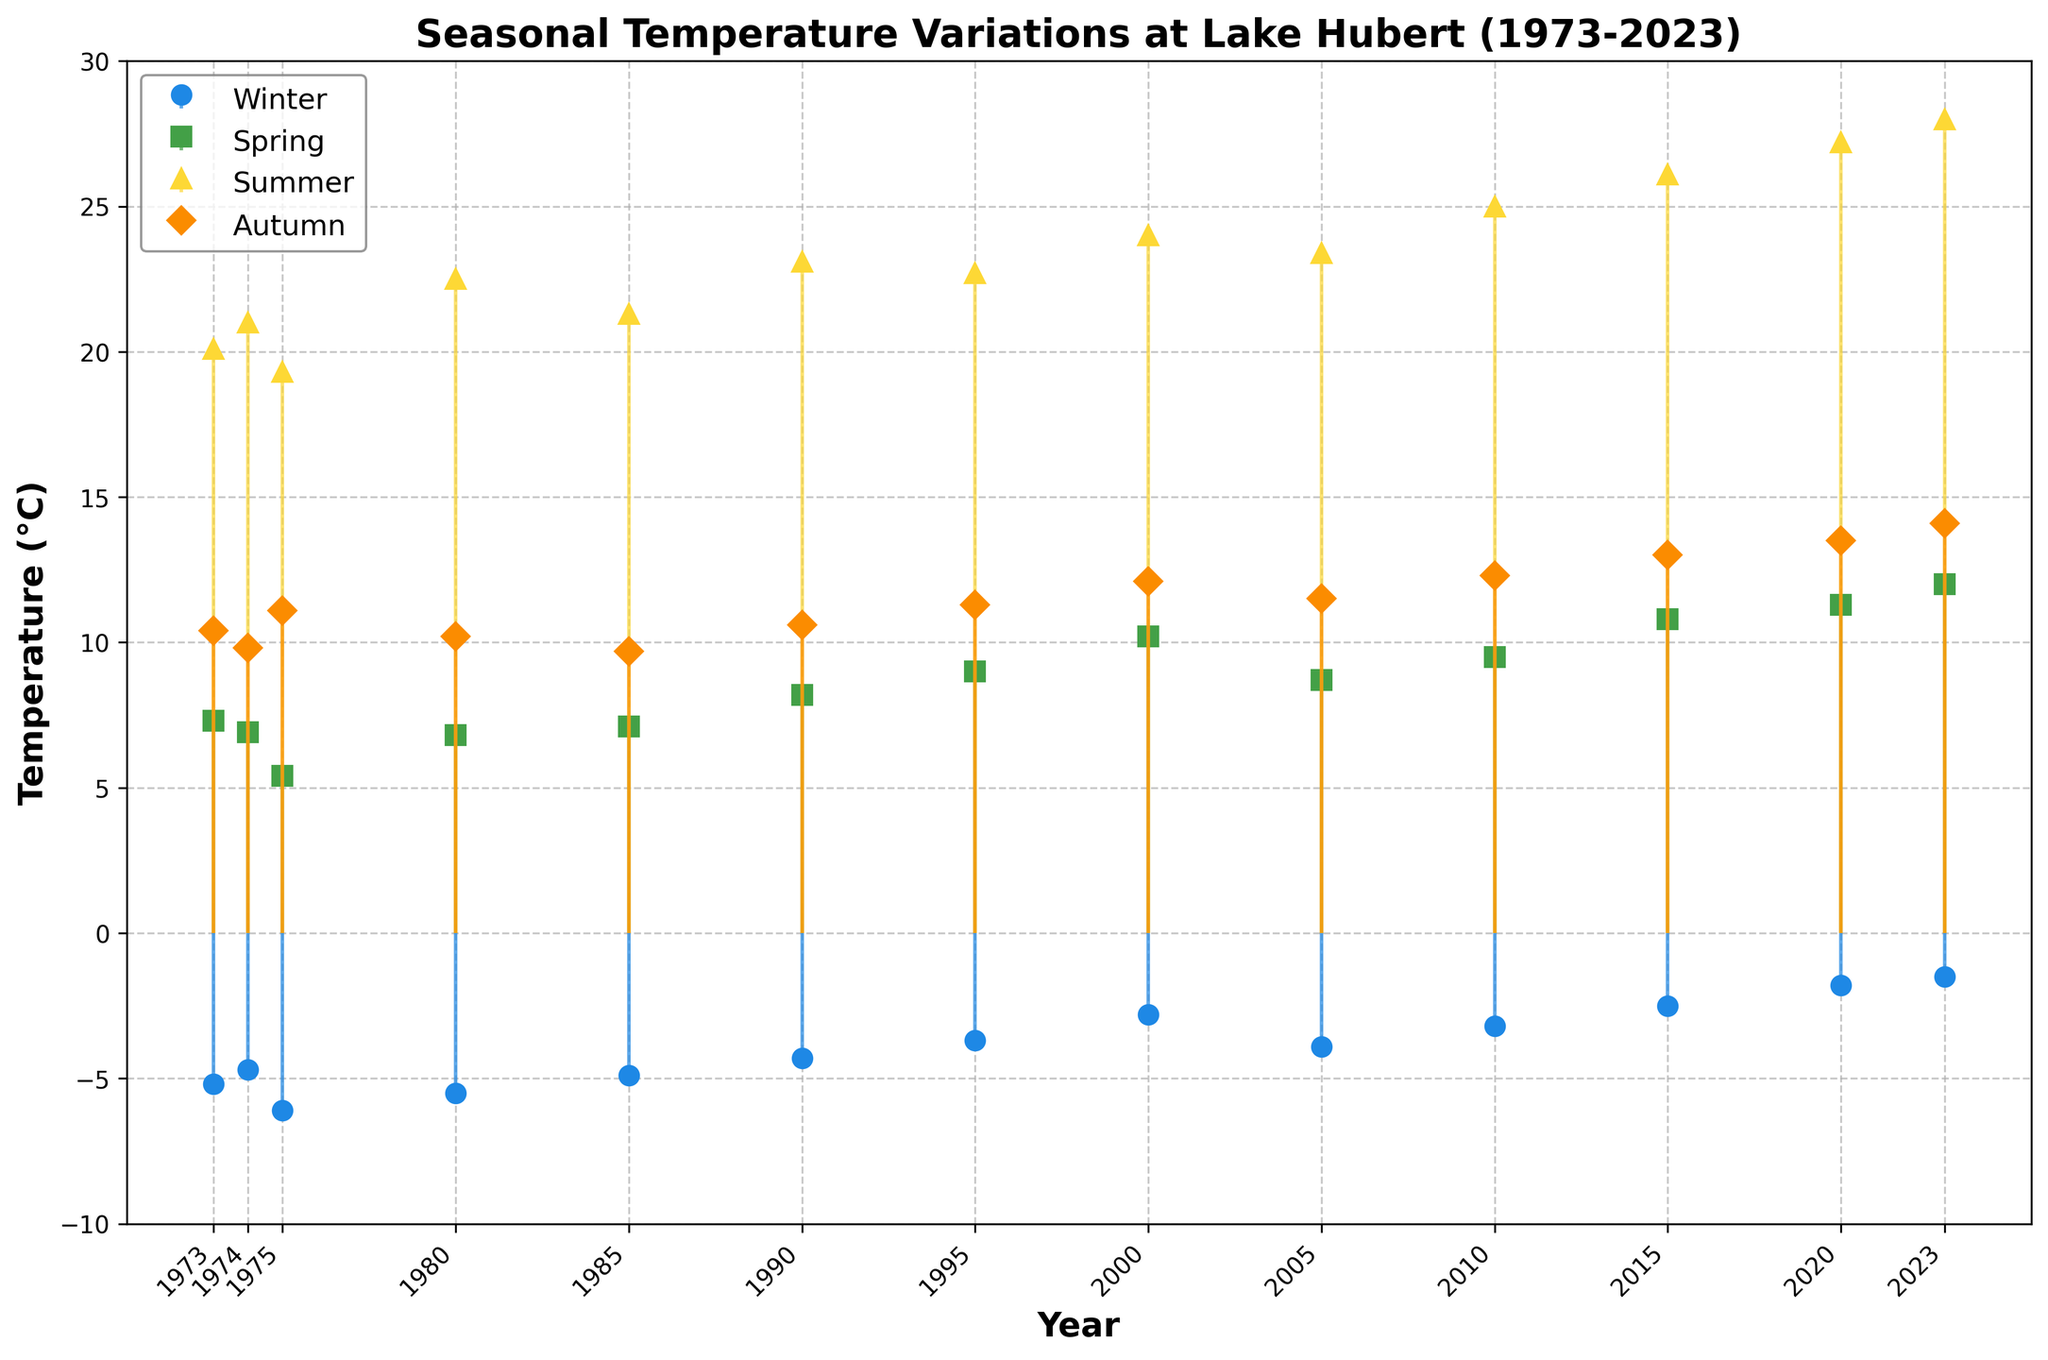What's the title of the figure? The title of the figure is prominently displayed at the top of the plot. It reads, "Seasonal Temperature Variations at Lake Hubert (1973-2023)."
Answer: Seasonal Temperature Variations at Lake Hubert (1973-2023) How many years' worth of data are shown in the plot? Count the number of points along the x-axis to determine the number of years represented. The x-axis shows data points for each year from 1973 to 2023. By counting each tick mark, you see there are 13 data points.
Answer: 13 years Which season shows the highest temperature during the year 2020? Observe the different colored lines and markers for each season in the year 2020. The yellow line (Summer Temp) reaches the highest point, indicating it's the hottest season in 2020.
Answer: Summer What is the range of winter temperatures from 1973 to 2023? Find the maximum and minimum data points for the Winter temperatures (blue markers) from the year 1973 to 2023. The highest winter temperature is -1.5°C in 2023, and the lowest is -6.1°C in 1975. The range is the difference between these values.
Answer: 4.6°C Calculate the average spring temperature for the years 1990, 2000, and 2010. Find the Spring temperatures for the years 1990 (8.2°C), 2000 (10.2°C), and 2010 (9.5°C). Add these temperatures together and then divide by the number of years (3). (8.2 + 10.2 + 9.5) / 3 = 9.3°C
Answer: 9.3°C Which year shows the smallest difference between summer and winter temperatures? Calculate the temperature difference between summer and winter for each year and identify the smallest difference. For example, in 2010, the difference is 25 - (-3.2) = 28.2°C. Check for all years and find the smallest one. The smallest difference is in 1975 with 19.3 - (-6.1) = 25.4°C.
Answer: 1975 What trend can you observe in the summer temperatures from 1973 to 2023? Observe the general direction of the yellow markers (Summer Temp) over the years. The temperatures increase from around 20.1°C in 1973 to 28.0°C in 2023, showing a rising trend.
Answer: Increasing trend How do the autumn temperatures in 1973 and 2023 compare? Identify the temperatures for autumn in the years 1973 and 2023 from the orange markers. In 1973, it's 10.4°C, and in 2023, it is 14.1°C. Compare these values.
Answer: 2023 is higher What can you infer about the overall seasonal temperature trends over the 50 years? Analyzing all the markers for each season from 1973 to 2023, you notice that temperatures in all seasons (Winter, Spring, Summer, Autumn) show an increasing trend. This suggests that the overall seasonal temperatures have risen over the 50 years.
Answer: Rising trend 